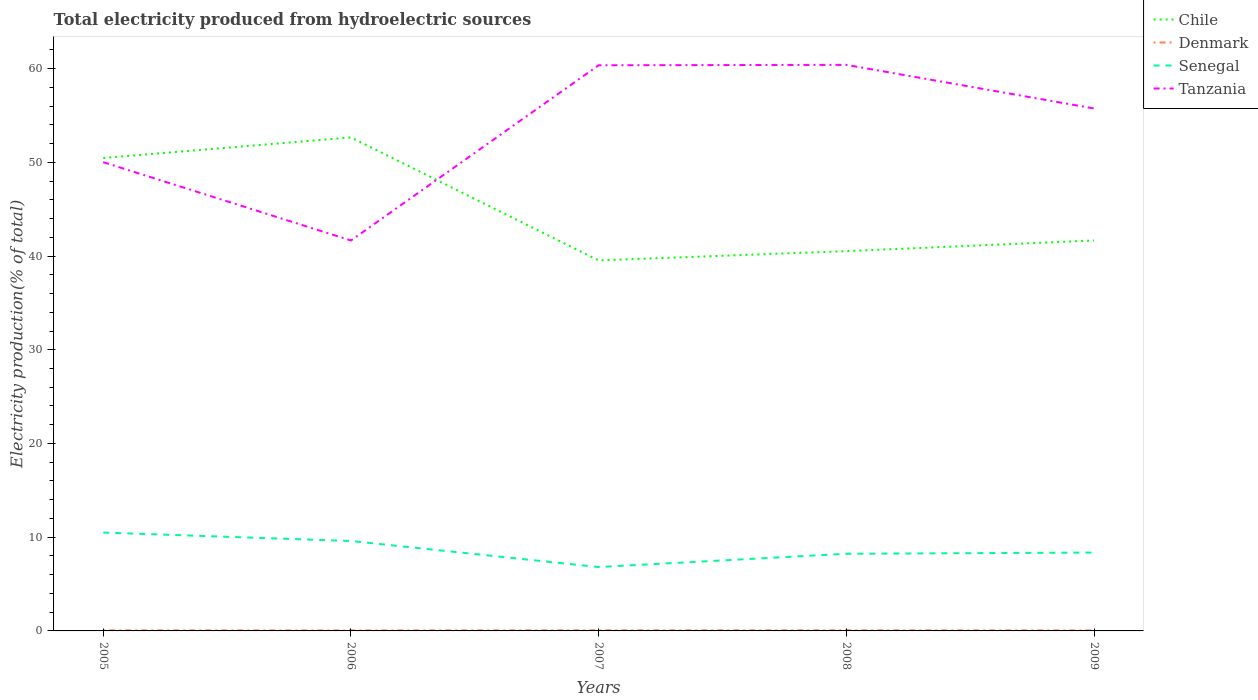How many different coloured lines are there?
Provide a succinct answer. 4. Does the line corresponding to Tanzania intersect with the line corresponding to Senegal?
Ensure brevity in your answer.  No. Is the number of lines equal to the number of legend labels?
Provide a succinct answer. Yes. Across all years, what is the maximum total electricity produced in Chile?
Provide a short and direct response. 39.53. What is the total total electricity produced in Chile in the graph?
Your answer should be very brief. 8.8. What is the difference between the highest and the second highest total electricity produced in Chile?
Provide a short and direct response. 13.12. What is the difference between the highest and the lowest total electricity produced in Denmark?
Offer a terse response. 3. Are the values on the major ticks of Y-axis written in scientific E-notation?
Offer a terse response. No. Does the graph contain any zero values?
Provide a short and direct response. No. Where does the legend appear in the graph?
Keep it short and to the point. Top right. How many legend labels are there?
Offer a very short reply. 4. How are the legend labels stacked?
Your answer should be compact. Vertical. What is the title of the graph?
Give a very brief answer. Total electricity produced from hydroelectric sources. Does "Northern Mariana Islands" appear as one of the legend labels in the graph?
Provide a succinct answer. No. What is the Electricity production(% of total) of Chile in 2005?
Your answer should be compact. 50.46. What is the Electricity production(% of total) in Denmark in 2005?
Provide a succinct answer. 0.06. What is the Electricity production(% of total) of Senegal in 2005?
Your answer should be very brief. 10.5. What is the Electricity production(% of total) of Tanzania in 2005?
Offer a very short reply. 50.01. What is the Electricity production(% of total) of Chile in 2006?
Provide a short and direct response. 52.66. What is the Electricity production(% of total) of Denmark in 2006?
Your answer should be compact. 0.05. What is the Electricity production(% of total) in Senegal in 2006?
Give a very brief answer. 9.59. What is the Electricity production(% of total) of Tanzania in 2006?
Your answer should be very brief. 41.66. What is the Electricity production(% of total) of Chile in 2007?
Keep it short and to the point. 39.53. What is the Electricity production(% of total) in Denmark in 2007?
Your response must be concise. 0.07. What is the Electricity production(% of total) of Senegal in 2007?
Keep it short and to the point. 6.81. What is the Electricity production(% of total) of Tanzania in 2007?
Provide a short and direct response. 60.35. What is the Electricity production(% of total) of Chile in 2008?
Provide a succinct answer. 40.52. What is the Electricity production(% of total) in Denmark in 2008?
Ensure brevity in your answer.  0.07. What is the Electricity production(% of total) of Senegal in 2008?
Your response must be concise. 8.23. What is the Electricity production(% of total) of Tanzania in 2008?
Offer a terse response. 60.4. What is the Electricity production(% of total) of Chile in 2009?
Make the answer very short. 41.66. What is the Electricity production(% of total) of Denmark in 2009?
Offer a terse response. 0.05. What is the Electricity production(% of total) in Senegal in 2009?
Provide a short and direct response. 8.36. What is the Electricity production(% of total) of Tanzania in 2009?
Offer a very short reply. 55.74. Across all years, what is the maximum Electricity production(% of total) in Chile?
Keep it short and to the point. 52.66. Across all years, what is the maximum Electricity production(% of total) of Denmark?
Your answer should be compact. 0.07. Across all years, what is the maximum Electricity production(% of total) in Senegal?
Your response must be concise. 10.5. Across all years, what is the maximum Electricity production(% of total) of Tanzania?
Offer a terse response. 60.4. Across all years, what is the minimum Electricity production(% of total) in Chile?
Keep it short and to the point. 39.53. Across all years, what is the minimum Electricity production(% of total) in Denmark?
Your answer should be compact. 0.05. Across all years, what is the minimum Electricity production(% of total) of Senegal?
Your answer should be compact. 6.81. Across all years, what is the minimum Electricity production(% of total) of Tanzania?
Make the answer very short. 41.66. What is the total Electricity production(% of total) of Chile in the graph?
Offer a very short reply. 224.83. What is the total Electricity production(% of total) of Denmark in the graph?
Give a very brief answer. 0.31. What is the total Electricity production(% of total) in Senegal in the graph?
Your answer should be very brief. 43.5. What is the total Electricity production(% of total) in Tanzania in the graph?
Make the answer very short. 268.17. What is the difference between the Electricity production(% of total) of Chile in 2005 and that in 2006?
Ensure brevity in your answer.  -2.2. What is the difference between the Electricity production(% of total) of Denmark in 2005 and that in 2006?
Offer a terse response. 0.01. What is the difference between the Electricity production(% of total) of Senegal in 2005 and that in 2006?
Make the answer very short. 0.9. What is the difference between the Electricity production(% of total) in Tanzania in 2005 and that in 2006?
Keep it short and to the point. 8.35. What is the difference between the Electricity production(% of total) in Chile in 2005 and that in 2007?
Offer a very short reply. 10.93. What is the difference between the Electricity production(% of total) of Denmark in 2005 and that in 2007?
Offer a very short reply. -0.01. What is the difference between the Electricity production(% of total) of Senegal in 2005 and that in 2007?
Give a very brief answer. 3.68. What is the difference between the Electricity production(% of total) of Tanzania in 2005 and that in 2007?
Offer a very short reply. -10.34. What is the difference between the Electricity production(% of total) of Chile in 2005 and that in 2008?
Ensure brevity in your answer.  9.94. What is the difference between the Electricity production(% of total) in Denmark in 2005 and that in 2008?
Provide a succinct answer. -0.01. What is the difference between the Electricity production(% of total) of Senegal in 2005 and that in 2008?
Provide a succinct answer. 2.26. What is the difference between the Electricity production(% of total) in Tanzania in 2005 and that in 2008?
Your response must be concise. -10.38. What is the difference between the Electricity production(% of total) in Chile in 2005 and that in 2009?
Ensure brevity in your answer.  8.8. What is the difference between the Electricity production(% of total) in Denmark in 2005 and that in 2009?
Give a very brief answer. 0.01. What is the difference between the Electricity production(% of total) in Senegal in 2005 and that in 2009?
Make the answer very short. 2.13. What is the difference between the Electricity production(% of total) in Tanzania in 2005 and that in 2009?
Offer a very short reply. -5.73. What is the difference between the Electricity production(% of total) in Chile in 2006 and that in 2007?
Give a very brief answer. 13.12. What is the difference between the Electricity production(% of total) in Denmark in 2006 and that in 2007?
Offer a very short reply. -0.02. What is the difference between the Electricity production(% of total) of Senegal in 2006 and that in 2007?
Offer a very short reply. 2.78. What is the difference between the Electricity production(% of total) in Tanzania in 2006 and that in 2007?
Ensure brevity in your answer.  -18.69. What is the difference between the Electricity production(% of total) in Chile in 2006 and that in 2008?
Your answer should be very brief. 12.13. What is the difference between the Electricity production(% of total) in Denmark in 2006 and that in 2008?
Your response must be concise. -0.02. What is the difference between the Electricity production(% of total) of Senegal in 2006 and that in 2008?
Your answer should be compact. 1.36. What is the difference between the Electricity production(% of total) in Tanzania in 2006 and that in 2008?
Keep it short and to the point. -18.74. What is the difference between the Electricity production(% of total) in Chile in 2006 and that in 2009?
Make the answer very short. 11. What is the difference between the Electricity production(% of total) in Denmark in 2006 and that in 2009?
Offer a very short reply. -0. What is the difference between the Electricity production(% of total) of Senegal in 2006 and that in 2009?
Keep it short and to the point. 1.23. What is the difference between the Electricity production(% of total) in Tanzania in 2006 and that in 2009?
Your answer should be very brief. -14.08. What is the difference between the Electricity production(% of total) of Chile in 2007 and that in 2008?
Provide a succinct answer. -0.99. What is the difference between the Electricity production(% of total) in Denmark in 2007 and that in 2008?
Ensure brevity in your answer.  0. What is the difference between the Electricity production(% of total) of Senegal in 2007 and that in 2008?
Make the answer very short. -1.42. What is the difference between the Electricity production(% of total) in Tanzania in 2007 and that in 2008?
Offer a terse response. -0.04. What is the difference between the Electricity production(% of total) in Chile in 2007 and that in 2009?
Ensure brevity in your answer.  -2.13. What is the difference between the Electricity production(% of total) of Denmark in 2007 and that in 2009?
Keep it short and to the point. 0.02. What is the difference between the Electricity production(% of total) in Senegal in 2007 and that in 2009?
Give a very brief answer. -1.55. What is the difference between the Electricity production(% of total) in Tanzania in 2007 and that in 2009?
Ensure brevity in your answer.  4.61. What is the difference between the Electricity production(% of total) in Chile in 2008 and that in 2009?
Your answer should be very brief. -1.14. What is the difference between the Electricity production(% of total) of Denmark in 2008 and that in 2009?
Your answer should be compact. 0.02. What is the difference between the Electricity production(% of total) in Senegal in 2008 and that in 2009?
Provide a short and direct response. -0.13. What is the difference between the Electricity production(% of total) in Tanzania in 2008 and that in 2009?
Your response must be concise. 4.65. What is the difference between the Electricity production(% of total) of Chile in 2005 and the Electricity production(% of total) of Denmark in 2006?
Provide a short and direct response. 50.41. What is the difference between the Electricity production(% of total) in Chile in 2005 and the Electricity production(% of total) in Senegal in 2006?
Provide a succinct answer. 40.87. What is the difference between the Electricity production(% of total) in Chile in 2005 and the Electricity production(% of total) in Tanzania in 2006?
Your answer should be compact. 8.8. What is the difference between the Electricity production(% of total) in Denmark in 2005 and the Electricity production(% of total) in Senegal in 2006?
Your answer should be compact. -9.53. What is the difference between the Electricity production(% of total) in Denmark in 2005 and the Electricity production(% of total) in Tanzania in 2006?
Offer a terse response. -41.6. What is the difference between the Electricity production(% of total) of Senegal in 2005 and the Electricity production(% of total) of Tanzania in 2006?
Your answer should be compact. -31.16. What is the difference between the Electricity production(% of total) in Chile in 2005 and the Electricity production(% of total) in Denmark in 2007?
Offer a terse response. 50.39. What is the difference between the Electricity production(% of total) in Chile in 2005 and the Electricity production(% of total) in Senegal in 2007?
Your answer should be compact. 43.64. What is the difference between the Electricity production(% of total) in Chile in 2005 and the Electricity production(% of total) in Tanzania in 2007?
Give a very brief answer. -9.89. What is the difference between the Electricity production(% of total) of Denmark in 2005 and the Electricity production(% of total) of Senegal in 2007?
Your answer should be compact. -6.75. What is the difference between the Electricity production(% of total) of Denmark in 2005 and the Electricity production(% of total) of Tanzania in 2007?
Keep it short and to the point. -60.29. What is the difference between the Electricity production(% of total) of Senegal in 2005 and the Electricity production(% of total) of Tanzania in 2007?
Give a very brief answer. -49.86. What is the difference between the Electricity production(% of total) in Chile in 2005 and the Electricity production(% of total) in Denmark in 2008?
Your response must be concise. 50.39. What is the difference between the Electricity production(% of total) of Chile in 2005 and the Electricity production(% of total) of Senegal in 2008?
Keep it short and to the point. 42.23. What is the difference between the Electricity production(% of total) in Chile in 2005 and the Electricity production(% of total) in Tanzania in 2008?
Keep it short and to the point. -9.94. What is the difference between the Electricity production(% of total) in Denmark in 2005 and the Electricity production(% of total) in Senegal in 2008?
Provide a succinct answer. -8.17. What is the difference between the Electricity production(% of total) of Denmark in 2005 and the Electricity production(% of total) of Tanzania in 2008?
Keep it short and to the point. -60.33. What is the difference between the Electricity production(% of total) in Senegal in 2005 and the Electricity production(% of total) in Tanzania in 2008?
Keep it short and to the point. -49.9. What is the difference between the Electricity production(% of total) in Chile in 2005 and the Electricity production(% of total) in Denmark in 2009?
Offer a terse response. 50.41. What is the difference between the Electricity production(% of total) of Chile in 2005 and the Electricity production(% of total) of Senegal in 2009?
Offer a terse response. 42.1. What is the difference between the Electricity production(% of total) of Chile in 2005 and the Electricity production(% of total) of Tanzania in 2009?
Make the answer very short. -5.28. What is the difference between the Electricity production(% of total) in Denmark in 2005 and the Electricity production(% of total) in Senegal in 2009?
Your response must be concise. -8.3. What is the difference between the Electricity production(% of total) in Denmark in 2005 and the Electricity production(% of total) in Tanzania in 2009?
Keep it short and to the point. -55.68. What is the difference between the Electricity production(% of total) in Senegal in 2005 and the Electricity production(% of total) in Tanzania in 2009?
Ensure brevity in your answer.  -45.25. What is the difference between the Electricity production(% of total) of Chile in 2006 and the Electricity production(% of total) of Denmark in 2007?
Keep it short and to the point. 52.58. What is the difference between the Electricity production(% of total) of Chile in 2006 and the Electricity production(% of total) of Senegal in 2007?
Keep it short and to the point. 45.84. What is the difference between the Electricity production(% of total) of Chile in 2006 and the Electricity production(% of total) of Tanzania in 2007?
Give a very brief answer. -7.7. What is the difference between the Electricity production(% of total) of Denmark in 2006 and the Electricity production(% of total) of Senegal in 2007?
Give a very brief answer. -6.76. What is the difference between the Electricity production(% of total) in Denmark in 2006 and the Electricity production(% of total) in Tanzania in 2007?
Your answer should be very brief. -60.3. What is the difference between the Electricity production(% of total) in Senegal in 2006 and the Electricity production(% of total) in Tanzania in 2007?
Ensure brevity in your answer.  -50.76. What is the difference between the Electricity production(% of total) in Chile in 2006 and the Electricity production(% of total) in Denmark in 2008?
Your answer should be very brief. 52.58. What is the difference between the Electricity production(% of total) of Chile in 2006 and the Electricity production(% of total) of Senegal in 2008?
Make the answer very short. 44.42. What is the difference between the Electricity production(% of total) in Chile in 2006 and the Electricity production(% of total) in Tanzania in 2008?
Your answer should be compact. -7.74. What is the difference between the Electricity production(% of total) in Denmark in 2006 and the Electricity production(% of total) in Senegal in 2008?
Give a very brief answer. -8.18. What is the difference between the Electricity production(% of total) of Denmark in 2006 and the Electricity production(% of total) of Tanzania in 2008?
Make the answer very short. -60.35. What is the difference between the Electricity production(% of total) of Senegal in 2006 and the Electricity production(% of total) of Tanzania in 2008?
Provide a short and direct response. -50.8. What is the difference between the Electricity production(% of total) in Chile in 2006 and the Electricity production(% of total) in Denmark in 2009?
Offer a terse response. 52.6. What is the difference between the Electricity production(% of total) of Chile in 2006 and the Electricity production(% of total) of Senegal in 2009?
Your answer should be very brief. 44.29. What is the difference between the Electricity production(% of total) in Chile in 2006 and the Electricity production(% of total) in Tanzania in 2009?
Provide a short and direct response. -3.09. What is the difference between the Electricity production(% of total) in Denmark in 2006 and the Electricity production(% of total) in Senegal in 2009?
Your answer should be very brief. -8.31. What is the difference between the Electricity production(% of total) of Denmark in 2006 and the Electricity production(% of total) of Tanzania in 2009?
Your response must be concise. -55.69. What is the difference between the Electricity production(% of total) of Senegal in 2006 and the Electricity production(% of total) of Tanzania in 2009?
Ensure brevity in your answer.  -46.15. What is the difference between the Electricity production(% of total) of Chile in 2007 and the Electricity production(% of total) of Denmark in 2008?
Ensure brevity in your answer.  39.46. What is the difference between the Electricity production(% of total) of Chile in 2007 and the Electricity production(% of total) of Senegal in 2008?
Your answer should be very brief. 31.3. What is the difference between the Electricity production(% of total) of Chile in 2007 and the Electricity production(% of total) of Tanzania in 2008?
Provide a succinct answer. -20.86. What is the difference between the Electricity production(% of total) in Denmark in 2007 and the Electricity production(% of total) in Senegal in 2008?
Offer a terse response. -8.16. What is the difference between the Electricity production(% of total) of Denmark in 2007 and the Electricity production(% of total) of Tanzania in 2008?
Your answer should be very brief. -60.33. What is the difference between the Electricity production(% of total) of Senegal in 2007 and the Electricity production(% of total) of Tanzania in 2008?
Make the answer very short. -53.58. What is the difference between the Electricity production(% of total) in Chile in 2007 and the Electricity production(% of total) in Denmark in 2009?
Your answer should be very brief. 39.48. What is the difference between the Electricity production(% of total) in Chile in 2007 and the Electricity production(% of total) in Senegal in 2009?
Ensure brevity in your answer.  31.17. What is the difference between the Electricity production(% of total) of Chile in 2007 and the Electricity production(% of total) of Tanzania in 2009?
Ensure brevity in your answer.  -16.21. What is the difference between the Electricity production(% of total) in Denmark in 2007 and the Electricity production(% of total) in Senegal in 2009?
Provide a short and direct response. -8.29. What is the difference between the Electricity production(% of total) in Denmark in 2007 and the Electricity production(% of total) in Tanzania in 2009?
Offer a terse response. -55.67. What is the difference between the Electricity production(% of total) of Senegal in 2007 and the Electricity production(% of total) of Tanzania in 2009?
Provide a succinct answer. -48.93. What is the difference between the Electricity production(% of total) in Chile in 2008 and the Electricity production(% of total) in Denmark in 2009?
Offer a very short reply. 40.47. What is the difference between the Electricity production(% of total) of Chile in 2008 and the Electricity production(% of total) of Senegal in 2009?
Provide a short and direct response. 32.16. What is the difference between the Electricity production(% of total) of Chile in 2008 and the Electricity production(% of total) of Tanzania in 2009?
Ensure brevity in your answer.  -15.22. What is the difference between the Electricity production(% of total) in Denmark in 2008 and the Electricity production(% of total) in Senegal in 2009?
Your answer should be very brief. -8.29. What is the difference between the Electricity production(% of total) of Denmark in 2008 and the Electricity production(% of total) of Tanzania in 2009?
Offer a very short reply. -55.67. What is the difference between the Electricity production(% of total) of Senegal in 2008 and the Electricity production(% of total) of Tanzania in 2009?
Offer a very short reply. -47.51. What is the average Electricity production(% of total) of Chile per year?
Keep it short and to the point. 44.97. What is the average Electricity production(% of total) in Denmark per year?
Provide a succinct answer. 0.06. What is the average Electricity production(% of total) in Senegal per year?
Offer a terse response. 8.7. What is the average Electricity production(% of total) of Tanzania per year?
Provide a short and direct response. 53.63. In the year 2005, what is the difference between the Electricity production(% of total) of Chile and Electricity production(% of total) of Denmark?
Give a very brief answer. 50.4. In the year 2005, what is the difference between the Electricity production(% of total) in Chile and Electricity production(% of total) in Senegal?
Give a very brief answer. 39.96. In the year 2005, what is the difference between the Electricity production(% of total) of Chile and Electricity production(% of total) of Tanzania?
Give a very brief answer. 0.45. In the year 2005, what is the difference between the Electricity production(% of total) of Denmark and Electricity production(% of total) of Senegal?
Your answer should be very brief. -10.43. In the year 2005, what is the difference between the Electricity production(% of total) of Denmark and Electricity production(% of total) of Tanzania?
Your answer should be very brief. -49.95. In the year 2005, what is the difference between the Electricity production(% of total) of Senegal and Electricity production(% of total) of Tanzania?
Provide a succinct answer. -39.52. In the year 2006, what is the difference between the Electricity production(% of total) of Chile and Electricity production(% of total) of Denmark?
Ensure brevity in your answer.  52.6. In the year 2006, what is the difference between the Electricity production(% of total) of Chile and Electricity production(% of total) of Senegal?
Give a very brief answer. 43.06. In the year 2006, what is the difference between the Electricity production(% of total) in Chile and Electricity production(% of total) in Tanzania?
Offer a terse response. 11. In the year 2006, what is the difference between the Electricity production(% of total) in Denmark and Electricity production(% of total) in Senegal?
Keep it short and to the point. -9.54. In the year 2006, what is the difference between the Electricity production(% of total) of Denmark and Electricity production(% of total) of Tanzania?
Your response must be concise. -41.61. In the year 2006, what is the difference between the Electricity production(% of total) of Senegal and Electricity production(% of total) of Tanzania?
Give a very brief answer. -32.07. In the year 2007, what is the difference between the Electricity production(% of total) in Chile and Electricity production(% of total) in Denmark?
Give a very brief answer. 39.46. In the year 2007, what is the difference between the Electricity production(% of total) of Chile and Electricity production(% of total) of Senegal?
Keep it short and to the point. 32.72. In the year 2007, what is the difference between the Electricity production(% of total) of Chile and Electricity production(% of total) of Tanzania?
Make the answer very short. -20.82. In the year 2007, what is the difference between the Electricity production(% of total) of Denmark and Electricity production(% of total) of Senegal?
Your response must be concise. -6.74. In the year 2007, what is the difference between the Electricity production(% of total) in Denmark and Electricity production(% of total) in Tanzania?
Provide a succinct answer. -60.28. In the year 2007, what is the difference between the Electricity production(% of total) in Senegal and Electricity production(% of total) in Tanzania?
Your answer should be compact. -53.54. In the year 2008, what is the difference between the Electricity production(% of total) of Chile and Electricity production(% of total) of Denmark?
Keep it short and to the point. 40.45. In the year 2008, what is the difference between the Electricity production(% of total) of Chile and Electricity production(% of total) of Senegal?
Make the answer very short. 32.29. In the year 2008, what is the difference between the Electricity production(% of total) in Chile and Electricity production(% of total) in Tanzania?
Your answer should be very brief. -19.88. In the year 2008, what is the difference between the Electricity production(% of total) in Denmark and Electricity production(% of total) in Senegal?
Provide a short and direct response. -8.16. In the year 2008, what is the difference between the Electricity production(% of total) in Denmark and Electricity production(% of total) in Tanzania?
Ensure brevity in your answer.  -60.33. In the year 2008, what is the difference between the Electricity production(% of total) of Senegal and Electricity production(% of total) of Tanzania?
Give a very brief answer. -52.17. In the year 2009, what is the difference between the Electricity production(% of total) in Chile and Electricity production(% of total) in Denmark?
Your answer should be very brief. 41.61. In the year 2009, what is the difference between the Electricity production(% of total) of Chile and Electricity production(% of total) of Senegal?
Your answer should be compact. 33.3. In the year 2009, what is the difference between the Electricity production(% of total) of Chile and Electricity production(% of total) of Tanzania?
Your answer should be very brief. -14.08. In the year 2009, what is the difference between the Electricity production(% of total) of Denmark and Electricity production(% of total) of Senegal?
Keep it short and to the point. -8.31. In the year 2009, what is the difference between the Electricity production(% of total) of Denmark and Electricity production(% of total) of Tanzania?
Ensure brevity in your answer.  -55.69. In the year 2009, what is the difference between the Electricity production(% of total) in Senegal and Electricity production(% of total) in Tanzania?
Offer a very short reply. -47.38. What is the ratio of the Electricity production(% of total) in Denmark in 2005 to that in 2006?
Make the answer very short. 1.26. What is the ratio of the Electricity production(% of total) in Senegal in 2005 to that in 2006?
Keep it short and to the point. 1.09. What is the ratio of the Electricity production(% of total) in Tanzania in 2005 to that in 2006?
Provide a short and direct response. 1.2. What is the ratio of the Electricity production(% of total) of Chile in 2005 to that in 2007?
Your response must be concise. 1.28. What is the ratio of the Electricity production(% of total) in Denmark in 2005 to that in 2007?
Make the answer very short. 0.89. What is the ratio of the Electricity production(% of total) of Senegal in 2005 to that in 2007?
Give a very brief answer. 1.54. What is the ratio of the Electricity production(% of total) of Tanzania in 2005 to that in 2007?
Provide a short and direct response. 0.83. What is the ratio of the Electricity production(% of total) of Chile in 2005 to that in 2008?
Your answer should be compact. 1.25. What is the ratio of the Electricity production(% of total) of Denmark in 2005 to that in 2008?
Offer a terse response. 0.89. What is the ratio of the Electricity production(% of total) in Senegal in 2005 to that in 2008?
Give a very brief answer. 1.27. What is the ratio of the Electricity production(% of total) of Tanzania in 2005 to that in 2008?
Provide a short and direct response. 0.83. What is the ratio of the Electricity production(% of total) of Chile in 2005 to that in 2009?
Offer a very short reply. 1.21. What is the ratio of the Electricity production(% of total) in Denmark in 2005 to that in 2009?
Keep it short and to the point. 1.22. What is the ratio of the Electricity production(% of total) of Senegal in 2005 to that in 2009?
Provide a short and direct response. 1.25. What is the ratio of the Electricity production(% of total) of Tanzania in 2005 to that in 2009?
Give a very brief answer. 0.9. What is the ratio of the Electricity production(% of total) in Chile in 2006 to that in 2007?
Your answer should be compact. 1.33. What is the ratio of the Electricity production(% of total) of Denmark in 2006 to that in 2007?
Offer a very short reply. 0.71. What is the ratio of the Electricity production(% of total) of Senegal in 2006 to that in 2007?
Offer a very short reply. 1.41. What is the ratio of the Electricity production(% of total) of Tanzania in 2006 to that in 2007?
Offer a very short reply. 0.69. What is the ratio of the Electricity production(% of total) of Chile in 2006 to that in 2008?
Keep it short and to the point. 1.3. What is the ratio of the Electricity production(% of total) of Denmark in 2006 to that in 2008?
Provide a succinct answer. 0.71. What is the ratio of the Electricity production(% of total) in Senegal in 2006 to that in 2008?
Keep it short and to the point. 1.17. What is the ratio of the Electricity production(% of total) in Tanzania in 2006 to that in 2008?
Provide a succinct answer. 0.69. What is the ratio of the Electricity production(% of total) of Chile in 2006 to that in 2009?
Offer a terse response. 1.26. What is the ratio of the Electricity production(% of total) of Denmark in 2006 to that in 2009?
Your response must be concise. 0.97. What is the ratio of the Electricity production(% of total) in Senegal in 2006 to that in 2009?
Give a very brief answer. 1.15. What is the ratio of the Electricity production(% of total) in Tanzania in 2006 to that in 2009?
Provide a short and direct response. 0.75. What is the ratio of the Electricity production(% of total) of Chile in 2007 to that in 2008?
Give a very brief answer. 0.98. What is the ratio of the Electricity production(% of total) of Senegal in 2007 to that in 2008?
Offer a terse response. 0.83. What is the ratio of the Electricity production(% of total) in Tanzania in 2007 to that in 2008?
Your answer should be very brief. 1. What is the ratio of the Electricity production(% of total) of Chile in 2007 to that in 2009?
Provide a short and direct response. 0.95. What is the ratio of the Electricity production(% of total) of Denmark in 2007 to that in 2009?
Provide a short and direct response. 1.36. What is the ratio of the Electricity production(% of total) of Senegal in 2007 to that in 2009?
Keep it short and to the point. 0.81. What is the ratio of the Electricity production(% of total) in Tanzania in 2007 to that in 2009?
Make the answer very short. 1.08. What is the ratio of the Electricity production(% of total) of Chile in 2008 to that in 2009?
Your answer should be very brief. 0.97. What is the ratio of the Electricity production(% of total) of Denmark in 2008 to that in 2009?
Offer a very short reply. 1.36. What is the ratio of the Electricity production(% of total) of Senegal in 2008 to that in 2009?
Give a very brief answer. 0.98. What is the ratio of the Electricity production(% of total) in Tanzania in 2008 to that in 2009?
Your answer should be very brief. 1.08. What is the difference between the highest and the second highest Electricity production(% of total) of Chile?
Provide a succinct answer. 2.2. What is the difference between the highest and the second highest Electricity production(% of total) of Senegal?
Offer a terse response. 0.9. What is the difference between the highest and the second highest Electricity production(% of total) in Tanzania?
Offer a terse response. 0.04. What is the difference between the highest and the lowest Electricity production(% of total) of Chile?
Make the answer very short. 13.12. What is the difference between the highest and the lowest Electricity production(% of total) of Denmark?
Provide a succinct answer. 0.02. What is the difference between the highest and the lowest Electricity production(% of total) in Senegal?
Ensure brevity in your answer.  3.68. What is the difference between the highest and the lowest Electricity production(% of total) of Tanzania?
Give a very brief answer. 18.74. 